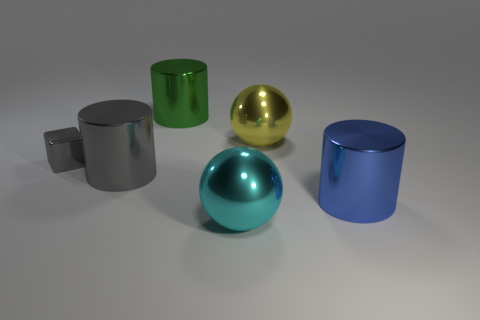Is there anything else that has the same size as the block?
Your answer should be very brief. No. There is a yellow object behind the big metal thing in front of the large blue cylinder; what shape is it?
Your response must be concise. Sphere. Are there fewer gray cylinders that are right of the green thing than tiny brown metal cylinders?
Offer a terse response. No. What shape is the cyan object?
Make the answer very short. Sphere. What is the size of the cylinder left of the large green metallic cylinder?
Your response must be concise. Large. What color is the metal sphere that is the same size as the cyan object?
Make the answer very short. Yellow. Are there any big metallic objects that have the same color as the tiny thing?
Offer a terse response. Yes. Are there fewer large shiny things that are in front of the tiny cube than metal things that are in front of the big green metal thing?
Offer a very short reply. Yes. There is a cylinder that is both in front of the large green thing and to the right of the gray cylinder; what is it made of?
Keep it short and to the point. Metal. Do the yellow metallic object and the cyan metallic object that is right of the small shiny block have the same shape?
Make the answer very short. Yes. 